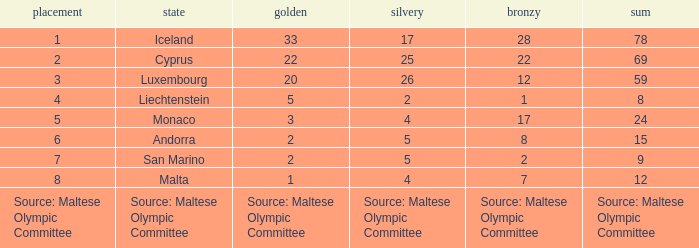What is the number of gold medals when the number of bronze medals is 8? 2.0. 